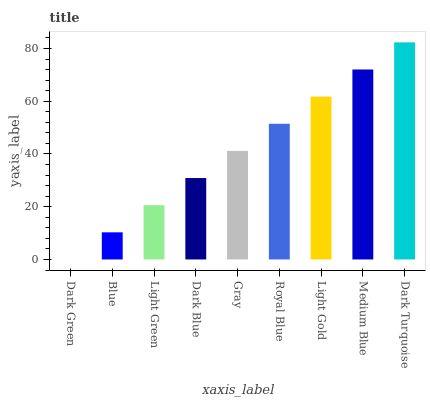Is Dark Green the minimum?
Answer yes or no. Yes. Is Dark Turquoise the maximum?
Answer yes or no. Yes. Is Blue the minimum?
Answer yes or no. No. Is Blue the maximum?
Answer yes or no. No. Is Blue greater than Dark Green?
Answer yes or no. Yes. Is Dark Green less than Blue?
Answer yes or no. Yes. Is Dark Green greater than Blue?
Answer yes or no. No. Is Blue less than Dark Green?
Answer yes or no. No. Is Gray the high median?
Answer yes or no. Yes. Is Gray the low median?
Answer yes or no. Yes. Is Dark Turquoise the high median?
Answer yes or no. No. Is Light Gold the low median?
Answer yes or no. No. 